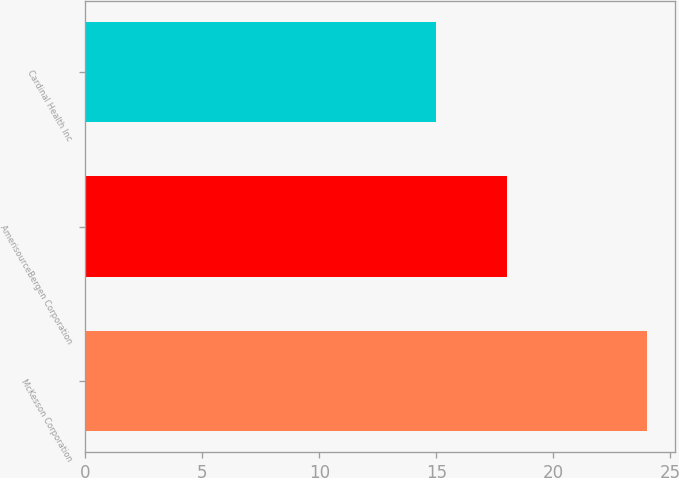<chart> <loc_0><loc_0><loc_500><loc_500><bar_chart><fcel>McKesson Corporation<fcel>AmerisourceBergen Corporation<fcel>Cardinal Health Inc<nl><fcel>24<fcel>18<fcel>15<nl></chart> 